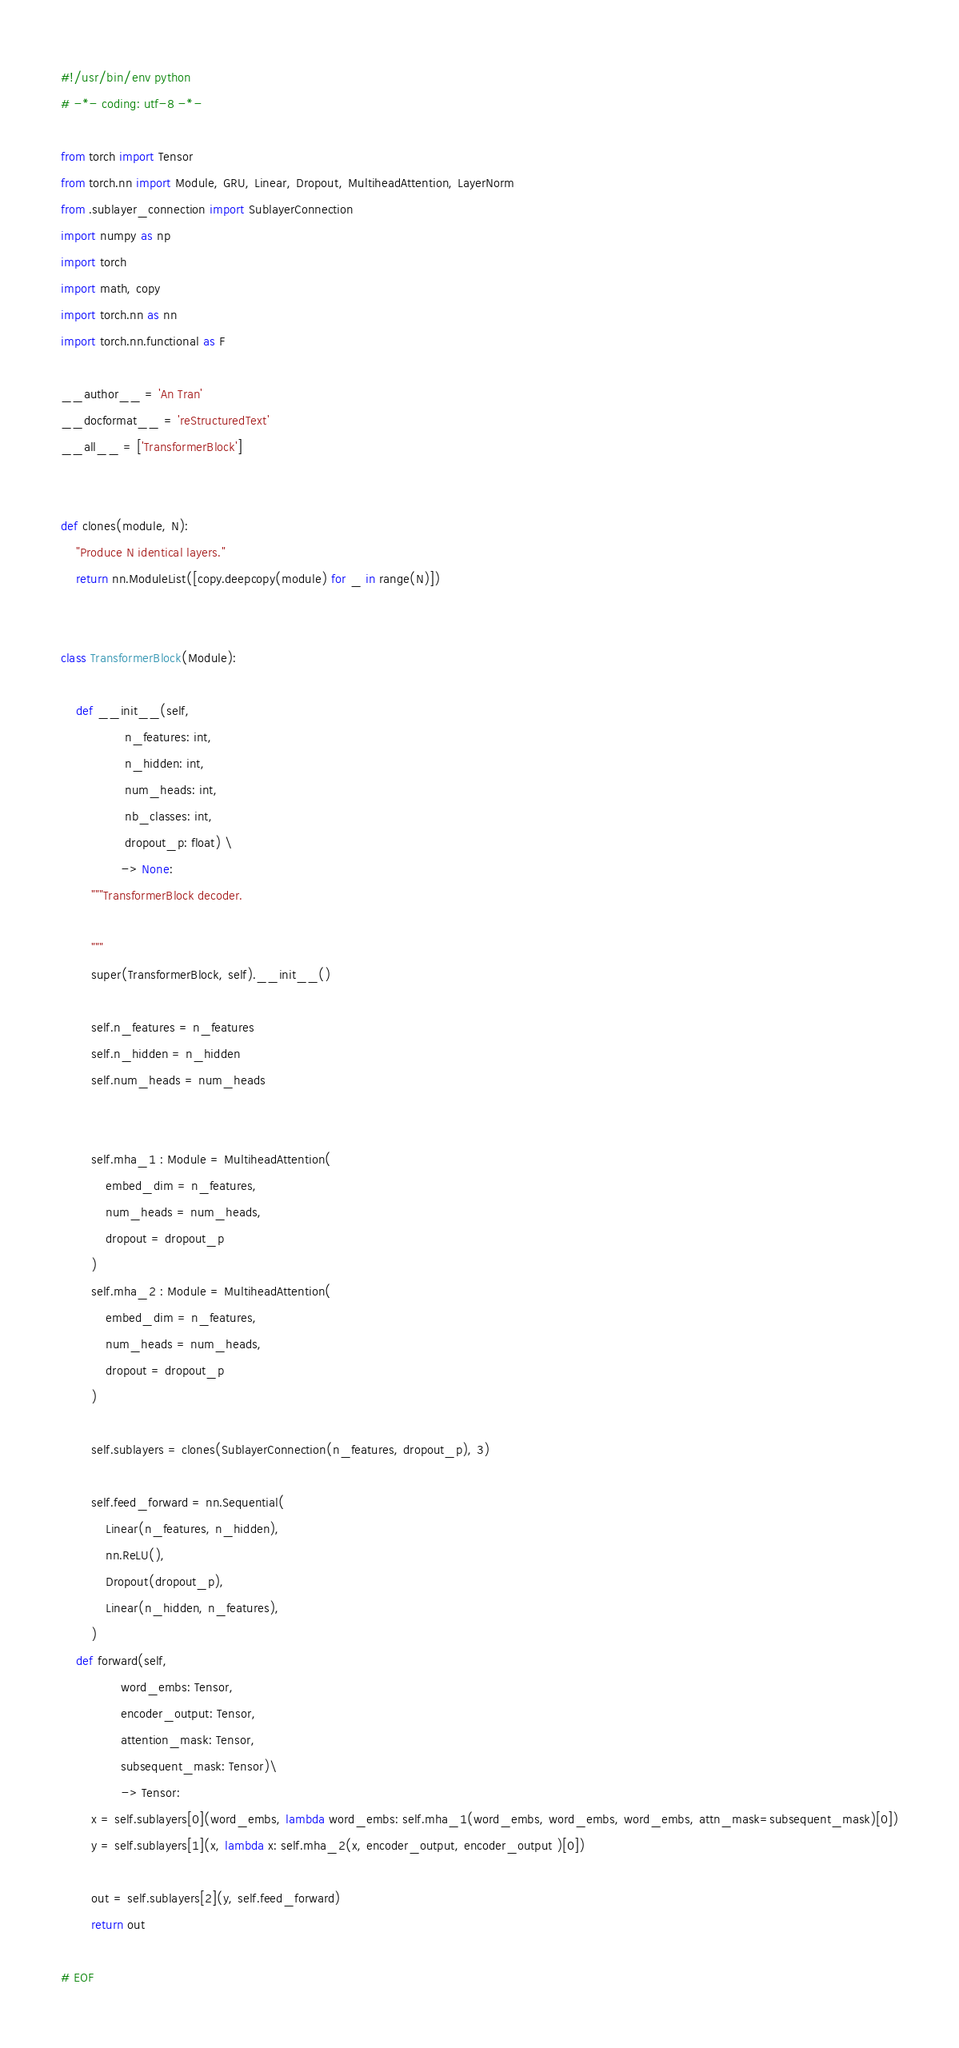<code> <loc_0><loc_0><loc_500><loc_500><_Python_>#!/usr/bin/env python
# -*- coding: utf-8 -*-

from torch import Tensor
from torch.nn import Module, GRU, Linear, Dropout, MultiheadAttention, LayerNorm
from .sublayer_connection import SublayerConnection
import numpy as np
import torch
import math, copy
import torch.nn as nn
import torch.nn.functional as F

__author__ = 'An Tran'
__docformat__ = 'reStructuredText'
__all__ = ['TransformerBlock']


def clones(module, N):
    "Produce N identical layers."
    return nn.ModuleList([copy.deepcopy(module) for _ in range(N)])
    

class TransformerBlock(Module):

    def __init__(self,
                 n_features: int,
                 n_hidden: int,
                 num_heads: int,
                 nb_classes: int,
                 dropout_p: float) \
                -> None:
        """TransformerBlock decoder.

        """
        super(TransformerBlock, self).__init__()

        self.n_features = n_features
        self.n_hidden = n_hidden
        self.num_heads = num_heads
        
        
        self.mha_1 : Module = MultiheadAttention(
            embed_dim = n_features,
            num_heads = num_heads,
            dropout = dropout_p 
        )
        self.mha_2 : Module = MultiheadAttention(
            embed_dim = n_features,
            num_heads = num_heads,
            dropout = dropout_p 
        )
        
        self.sublayers = clones(SublayerConnection(n_features, dropout_p), 3)

        self.feed_forward = nn.Sequential(
            Linear(n_features, n_hidden),
            nn.ReLU(),
            Dropout(dropout_p),
            Linear(n_hidden, n_features),
        )
    def forward(self,
                word_embs: Tensor,
                encoder_output: Tensor,
                attention_mask: Tensor,
                subsequent_mask: Tensor)\
                -> Tensor:
        x = self.sublayers[0](word_embs, lambda word_embs: self.mha_1(word_embs, word_embs, word_embs, attn_mask=subsequent_mask)[0])
        y = self.sublayers[1](x, lambda x: self.mha_2(x, encoder_output, encoder_output )[0])
        
        out = self.sublayers[2](y, self.feed_forward)        
        return out
            
# EOF</code> 